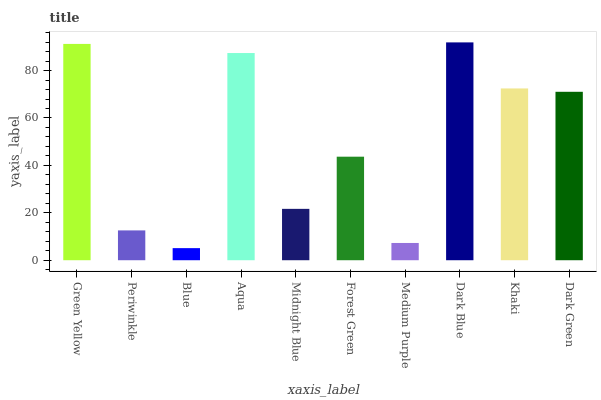Is Blue the minimum?
Answer yes or no. Yes. Is Dark Blue the maximum?
Answer yes or no. Yes. Is Periwinkle the minimum?
Answer yes or no. No. Is Periwinkle the maximum?
Answer yes or no. No. Is Green Yellow greater than Periwinkle?
Answer yes or no. Yes. Is Periwinkle less than Green Yellow?
Answer yes or no. Yes. Is Periwinkle greater than Green Yellow?
Answer yes or no. No. Is Green Yellow less than Periwinkle?
Answer yes or no. No. Is Dark Green the high median?
Answer yes or no. Yes. Is Forest Green the low median?
Answer yes or no. Yes. Is Khaki the high median?
Answer yes or no. No. Is Dark Blue the low median?
Answer yes or no. No. 